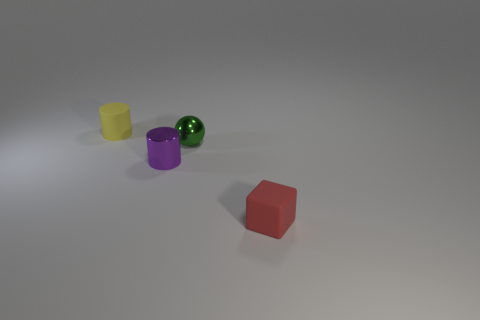Are there fewer gray matte cylinders than tiny yellow cylinders?
Offer a very short reply. Yes. The matte thing in front of the matte object on the left side of the red cube that is to the right of the yellow object is what shape?
Ensure brevity in your answer.  Cube. Is there a small red block made of the same material as the yellow object?
Your answer should be compact. Yes. Do the tiny rubber object to the right of the tiny green metallic sphere and the tiny cylinder in front of the small green shiny ball have the same color?
Ensure brevity in your answer.  No. Are there fewer small things that are in front of the green sphere than yellow metallic cylinders?
Make the answer very short. No. How many things are either rubber objects or small matte objects behind the green metal object?
Provide a succinct answer. 2. What is the color of the tiny cylinder that is made of the same material as the small green object?
Your response must be concise. Purple. How many things are small metallic cylinders or green objects?
Keep it short and to the point. 2. There is a metal cylinder that is the same size as the rubber cylinder; what is its color?
Keep it short and to the point. Purple. How many things are either rubber cylinders that are left of the purple metal object or large cyan matte cylinders?
Offer a terse response. 1. 